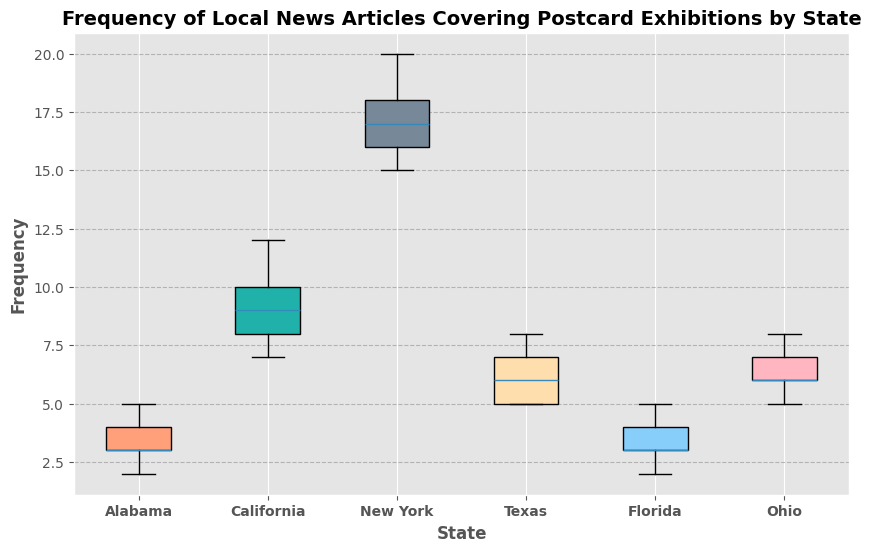What's the median frequency of local news articles in California? First, identify the frequency values for California: [10, 8, 12, 9, 7]. Arrange them in ascending order: [7, 8, 9, 10, 12]. The median value is the middle value, which is 9.
Answer: 9 Which state has the highest median frequency of local news articles? Median values: Alabama (3), California (9), New York (17), Texas (6), Florida (3), Ohio (6). New York has the highest median value of 17.
Answer: New York Which state shows the greatest range in frequency of local news articles? Compute the range (max - min) for each state. Alabama: 5-2=3, California: 12-7=5, New York: 20-15=5, Texas: 8-5=3, Florida: 5-2=3, Ohio: 8-5=3. Both California and New York have the largest range of 5.
Answer: California, New York What is the interquartile range (IQR) of local news article frequencies in Texas? Frequencies in Texas: [5, 7, 6, 5, 8]. Arrange in ascending order: [5, 5, 6, 7, 8]. IQR = Q3 - Q1. Q1 is the median of the lower half: 5. Q3 is the median of the upper half: 7. IQR = 7-5 = 2.
Answer: 2 Which state has the least variability in the frequency of local news articles? Variability can be judged by the range or spread of the data. Range: Alabama (3), California (5), New York (5), Texas (3), Florida (3), Ohio (3). Many states have similar ranges, but visually, Ohio seems to have the smallest spread.
Answer: Ohio What is the average frequency for local news articles in New York? Frequencies in New York: [15, 18, 17, 20, 16]. Sum them: 15+18+17+20+16=86. Divide by 5 (number of values): 86/5 = 17.2
Answer: 17.2 Which state features the most frequent outliers in the box plot? Outliers are generally depicted as dots outside the whiskers of the box plot. Upon viewing, none of the states show distinct outliers.
Answer: None Which color is used to represent Florida in the box plot? Each state is represented by a distinct color in the plot. Florida is represented by a light brown color.
Answer: Light Brown Compare the median frequency between Alabama and Texas. Which state is higher? Median values: Alabama (3), Texas (6). Texas has a higher median value.
Answer: Texas How many states have a median frequency greater than 8? Median values: Alabama (3), California (9), New York (17), Texas (6), Florida (3), Ohio (6). Two states have a median frequency greater than 8: California and New York.
Answer: 2 